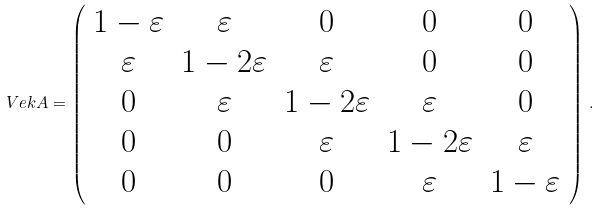Convert formula to latex. <formula><loc_0><loc_0><loc_500><loc_500>\ V e k { A } = \left ( \begin{array} { c c c c c } 1 - \varepsilon & { \varepsilon } & 0 & 0 & 0 \\ \varepsilon & { 1 - 2 \varepsilon } & \varepsilon & 0 & 0 \\ 0 & { \varepsilon } & 1 - 2 \varepsilon & \varepsilon & 0 \\ 0 & 0 & \varepsilon & 1 - 2 \varepsilon & \varepsilon \\ 0 & 0 & 0 & \varepsilon & 1 - \varepsilon \end{array} \right ) \, .</formula> 